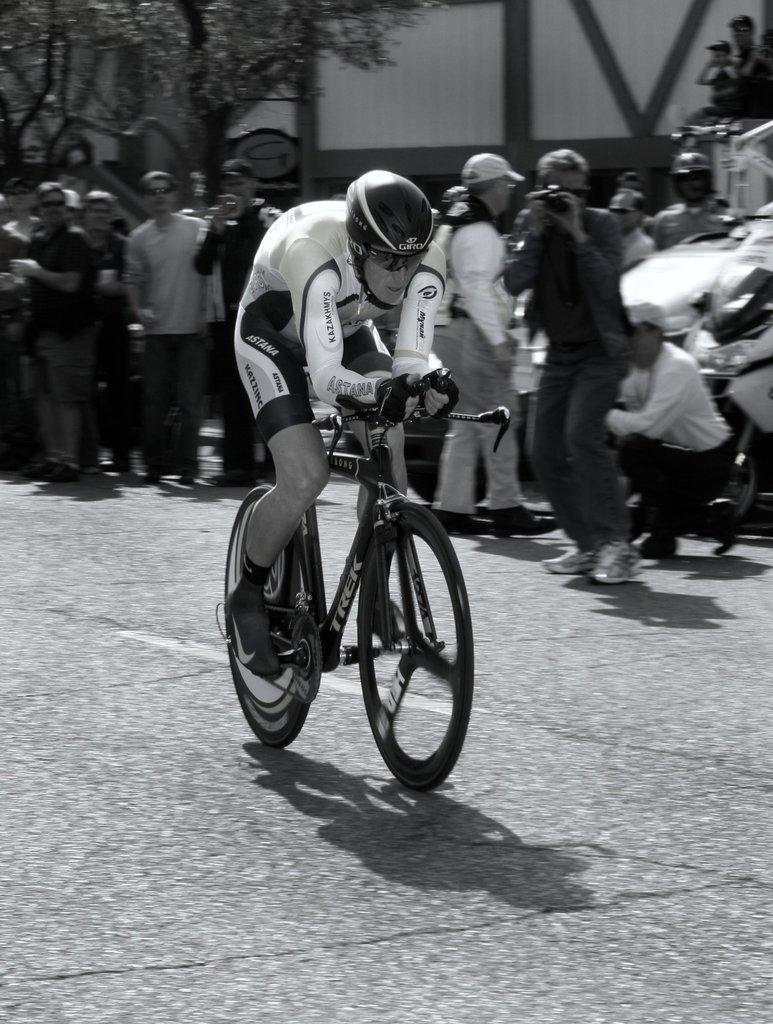What is the color scheme of the image? The image is black and white. What is the main subject of the image? There is a person riding a bicycle in the image. What safety precaution is the person on the bicycle taking? The person riding the bicycle is wearing a helmet. What are the other people in the image doing? The other people are standing nearby, taking a snapshot. What type of natural environment is visible in the image? Trees are visible in the image. What type of man-made structure can be seen in the image? There is at least one building in the image. How many words can be seen written on the bicycle in the image? There are no words visible on the bicycle in the image. What type of frogs are hopping around the person riding the bicycle? There are no frogs present in the image. 